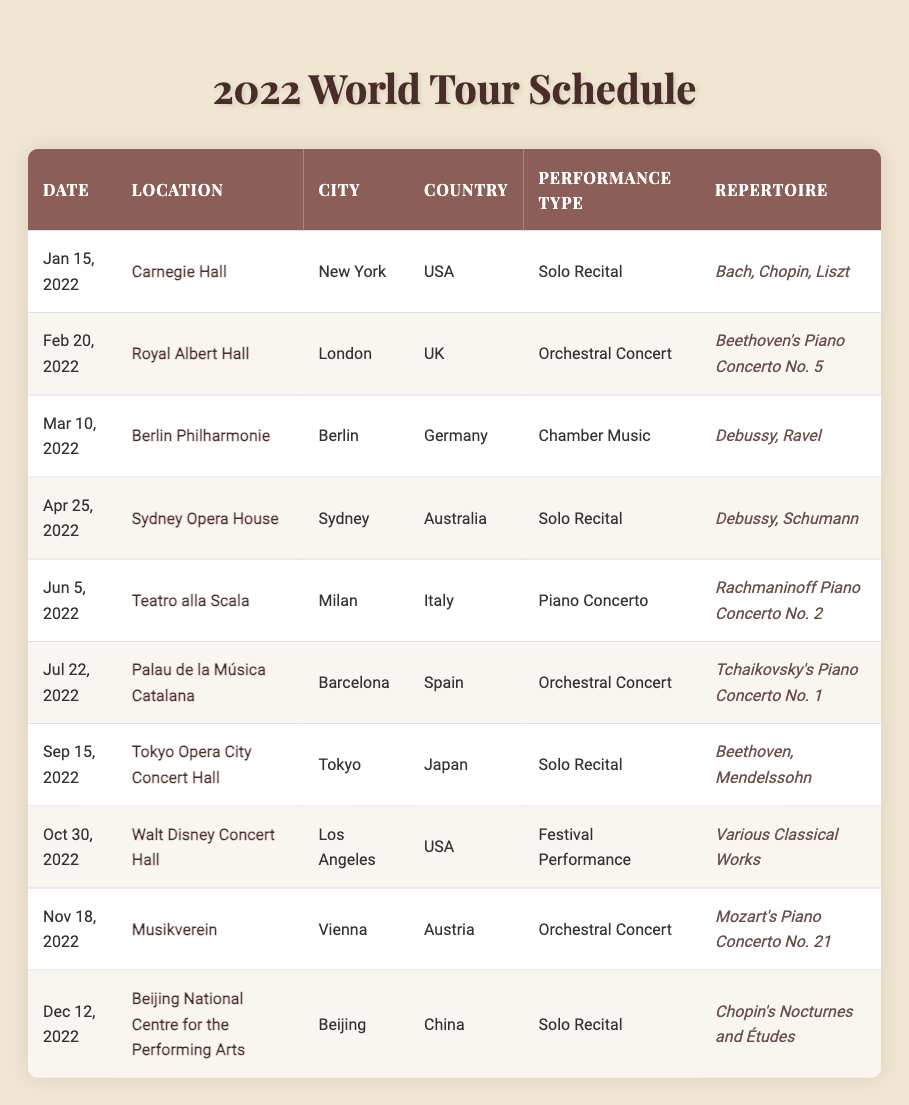What locations did the musician perform in December 2022? The table lists the performances in December 2022, and there is one entry on December 12, which is the Beijing National Centre for the Performing Arts, located in Beijing, China.
Answer: Beijing National Centre for the Performing Arts How many solo recitals did the musician perform in 2022? By examining the table, we can find the performances marked as "Solo Recital". These are on January 15, April 25, September 15, and December 12, totalling four solo recitals.
Answer: 4 Which city hosted the orchestral concert featuring Mozart's Piano Concerto No. 21? Looking through the table, the entry for Mozart's Piano Concerto No. 21 is on November 18, 2022, held at the Musikverein in Vienna, Austria. The city is Vienna.
Answer: Vienna In which country did the musician perform Rachmaninoff's Piano Concerto No. 2? The table reveals that Rachmaninoff's Piano Concerto No. 2 was performed on June 5, 2022, at Teatro alla Scala in Milan, Italy. Therefore, the country is Italy.
Answer: Italy What is the total number of performances in the USA? The table shows performances on January 15 at Carnegie Hall in New York and October 30 at Walt Disney Concert Hall in Los Angeles, leading to a total of two performances in the USA.
Answer: 2 Was there a performance in Australia in 2022? Checking through the table, there is a performance listed on April 25, 2022, at the Sydney Opera House in Sydney, Australia, confirming that yes, there was a performance in Australia.
Answer: Yes How many different performance types did the musician showcase during the tour? By reviewing the table, we can see five different performance types: Solo Recital, Orchestral Concert, Chamber Music, Piano Concerto, and Festival Performance. Therefore, there are five performance types.
Answer: 5 Which repertoire was performed at the performance in Berlin? The entry for the Berlin Philharmonie on March 10, 2022, shows that the repertoire performed there included works by Debussy and Ravel.
Answer: Debussy, Ravel How many performances took place in Europe? The performances in Europe according to the table are: Royal Albert Hall (London), Berlin Philharmonie (Berlin), Teatro alla Scala (Milan), Palau de la Música Catalana (Barcelona), Musikverein (Vienna). This gives a total of five performances in Europe.
Answer: 5 